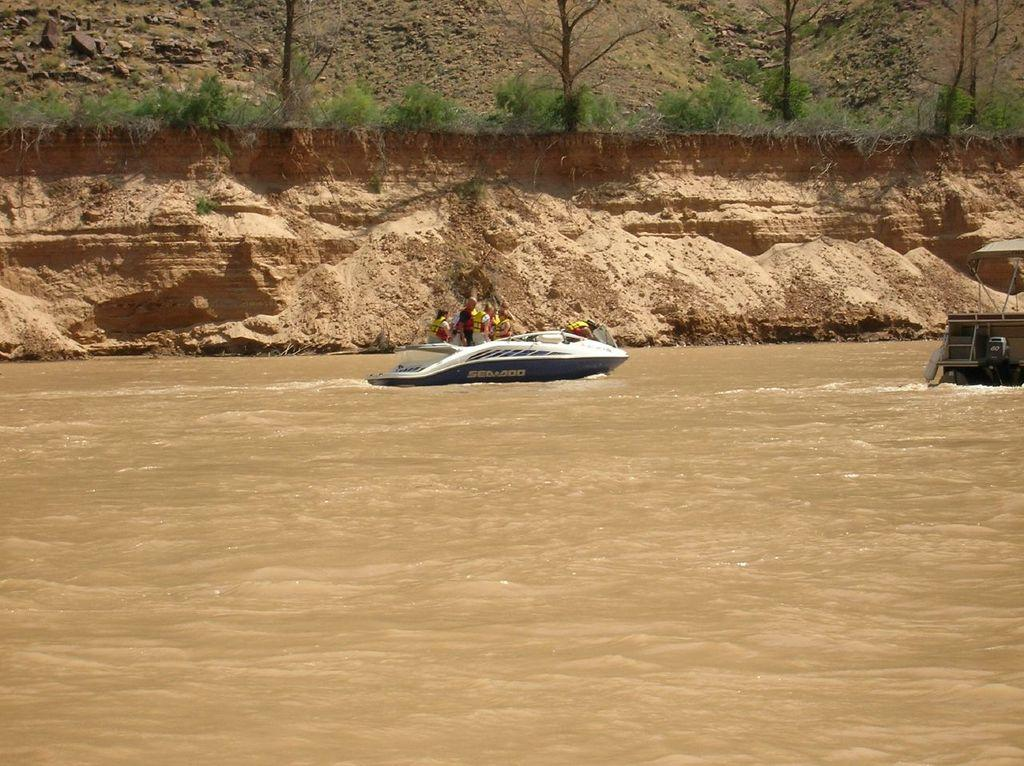What is at the bottom of the image? There is water at the bottom of the image. What can be seen floating on the water? There is a boat in the image. What is visible in the distance in the image? There is a mountain in the background of the image. What type of vegetation is present in the image? There are plants and trees in the image. What type of juice is being served in the boat in the image? There is no juice or any indication of a serving activity in the boat in the image. How many carts are present in the image? There are no carts present in the image. 